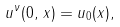<formula> <loc_0><loc_0><loc_500><loc_500>u ^ { \nu } ( 0 , \, x ) = u _ { 0 } ( x ) ,</formula> 